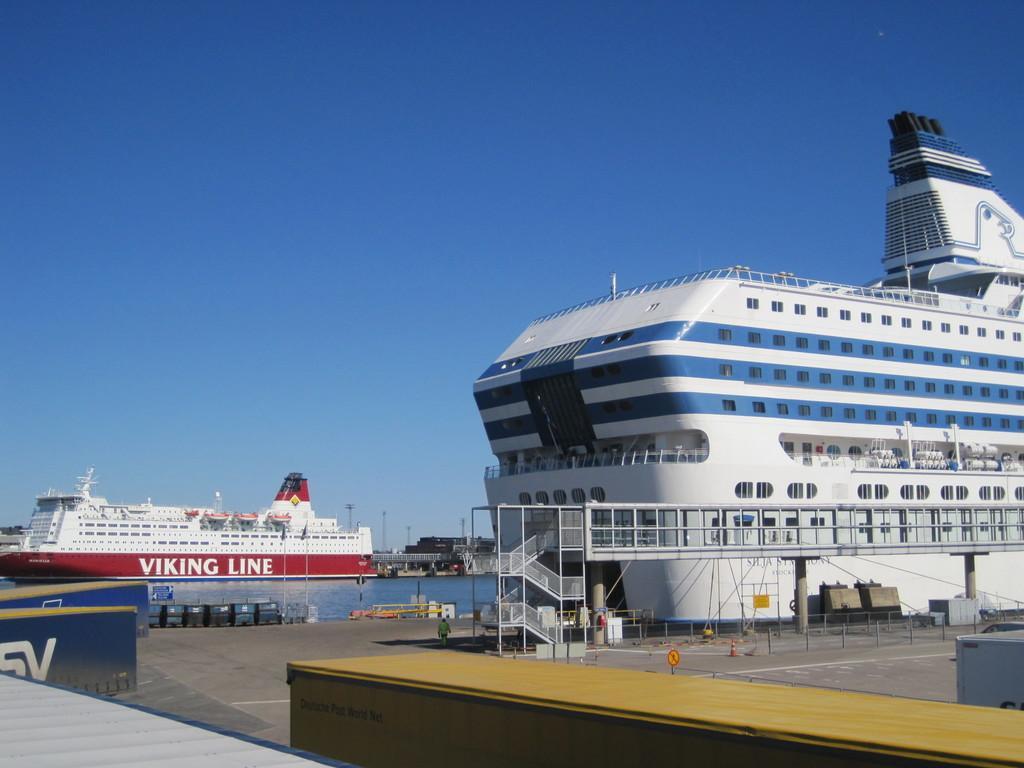Please provide a concise description of this image. In this picture I can see few ships and I can see few poles and few containers and a human walking and looks like a building in the back and I can see a blue sky and I can see metal staircase. 